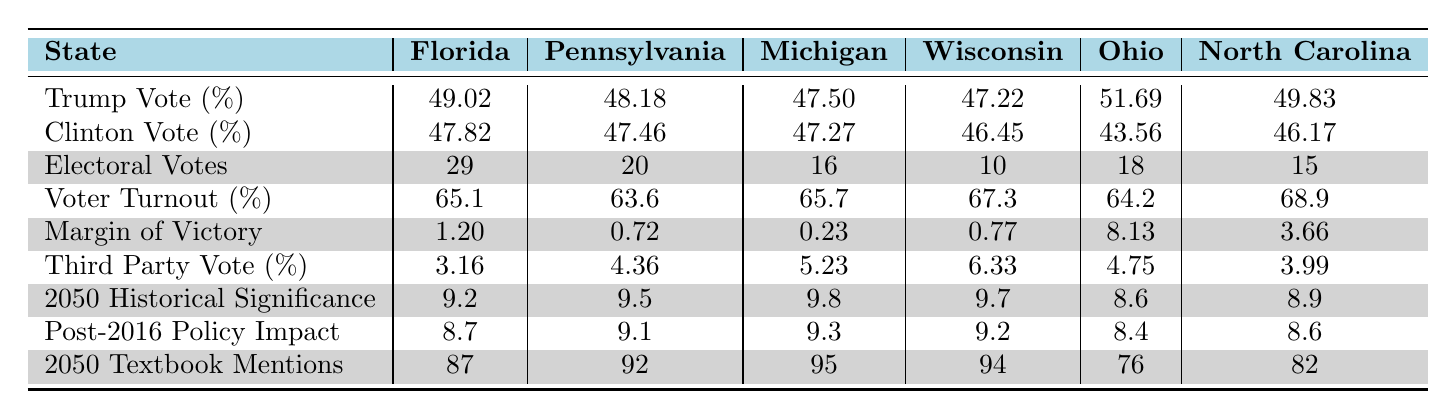What was the voter turnout percentage in Michigan? The table lists the voter turnout percentage for Michigan as 65.7%.
Answer: 65.7% Which state had the highest margin of victory? The table shows that Ohio had the highest margin of victory at 8.13% compared to other states.
Answer: Ohio What is the average electoral vote count of the swing states? The total electoral votes from the states are (29 + 20 + 16 + 10 + 18 + 15) = 108. There are 6 states, so the average is 108 / 6 = 18.
Answer: 18 Did Clinton receive more votes than Trump in Pennsylvania? The table indicates that Clinton received 47.46% and Trump received 48.18%, thus Clinton did not receive more votes.
Answer: No Which state had the lowest third-party vote percentage? By comparing the third-party vote percentages, Florida has the lowest percentage at 3.16%.
Answer: Florida What was the difference in voter turnout between Florida and North Carolina? The voter turnout in Florida is 65.1% and in North Carolina is 68.9%. The difference is 68.9 - 65.1 = 3.8%.
Answer: 3.8% Which state had the highest percentage of Trump votes, and what was that percentage? The table shows that Ohio had the highest percentage of Trump votes at 51.69%.
Answer: Ohio, 51.69% What is the total number of electoral votes for states where Trump won? The total electoral votes for Florida, Pennsylvania, Michigan, Wisconsin, Ohio, and North Carolina where Trump won (29 + 20 + 16 + 10 + 18 + 15) adds up to 108.
Answer: 108 What state had the closest margin of victory? According to the table, Michigan had the closest margin of victory at just 0.23%.
Answer: Michigan Based on the 2050 historical significance ratings, which state is considered the most significant, and what is its rating? The highest rating is for Michigan at 9.8, indicating it is the most significant state.
Answer: Michigan, 9.8 